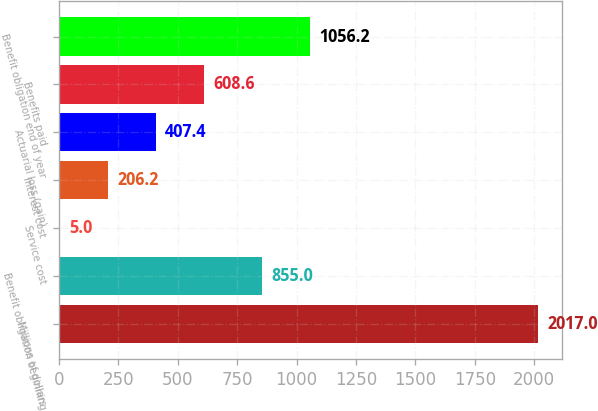Convert chart to OTSL. <chart><loc_0><loc_0><loc_500><loc_500><bar_chart><fcel>Millions of dollars<fcel>Benefit obligation beginning<fcel>Service cost<fcel>Interest cost<fcel>Actuarial loss (gain)<fcel>Benefits paid<fcel>Benefit obligation end of year<nl><fcel>2017<fcel>855<fcel>5<fcel>206.2<fcel>407.4<fcel>608.6<fcel>1056.2<nl></chart> 